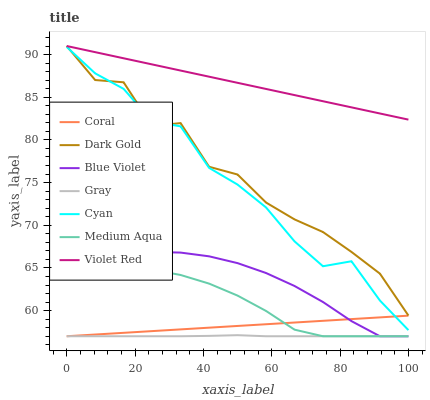Does Gray have the minimum area under the curve?
Answer yes or no. Yes. Does Violet Red have the maximum area under the curve?
Answer yes or no. Yes. Does Dark Gold have the minimum area under the curve?
Answer yes or no. No. Does Dark Gold have the maximum area under the curve?
Answer yes or no. No. Is Coral the smoothest?
Answer yes or no. Yes. Is Dark Gold the roughest?
Answer yes or no. Yes. Is Violet Red the smoothest?
Answer yes or no. No. Is Violet Red the roughest?
Answer yes or no. No. Does Gray have the lowest value?
Answer yes or no. Yes. Does Dark Gold have the lowest value?
Answer yes or no. No. Does Dark Gold have the highest value?
Answer yes or no. Yes. Does Coral have the highest value?
Answer yes or no. No. Is Coral less than Violet Red?
Answer yes or no. Yes. Is Cyan greater than Medium Aqua?
Answer yes or no. Yes. Does Medium Aqua intersect Coral?
Answer yes or no. Yes. Is Medium Aqua less than Coral?
Answer yes or no. No. Is Medium Aqua greater than Coral?
Answer yes or no. No. Does Coral intersect Violet Red?
Answer yes or no. No. 